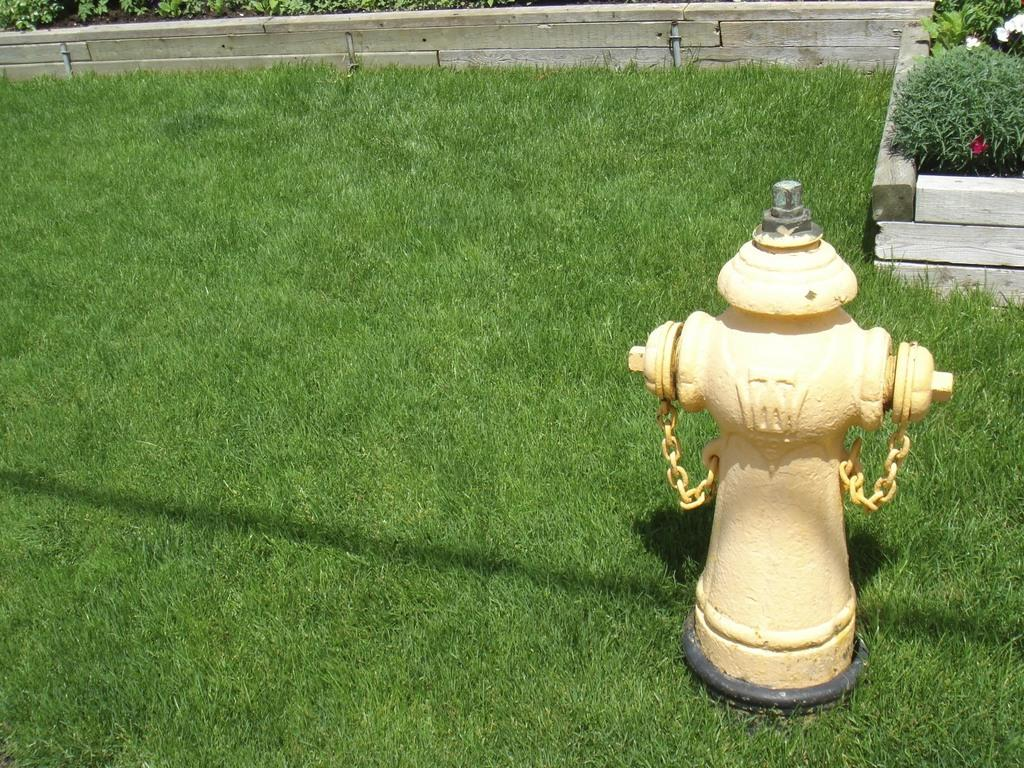What type of vegetation covers the land in the image? The land is covered with grass. What can be seen on the right side of the image? There is a hydrant and plants on the right side of the image. What is located at the top of the image? There is a wooden wall, pipes, and leaves at the top of the image. How does the toothbrush help clean the leaves in the image? There is no toothbrush present in the image, so it cannot help clean the leaves. 